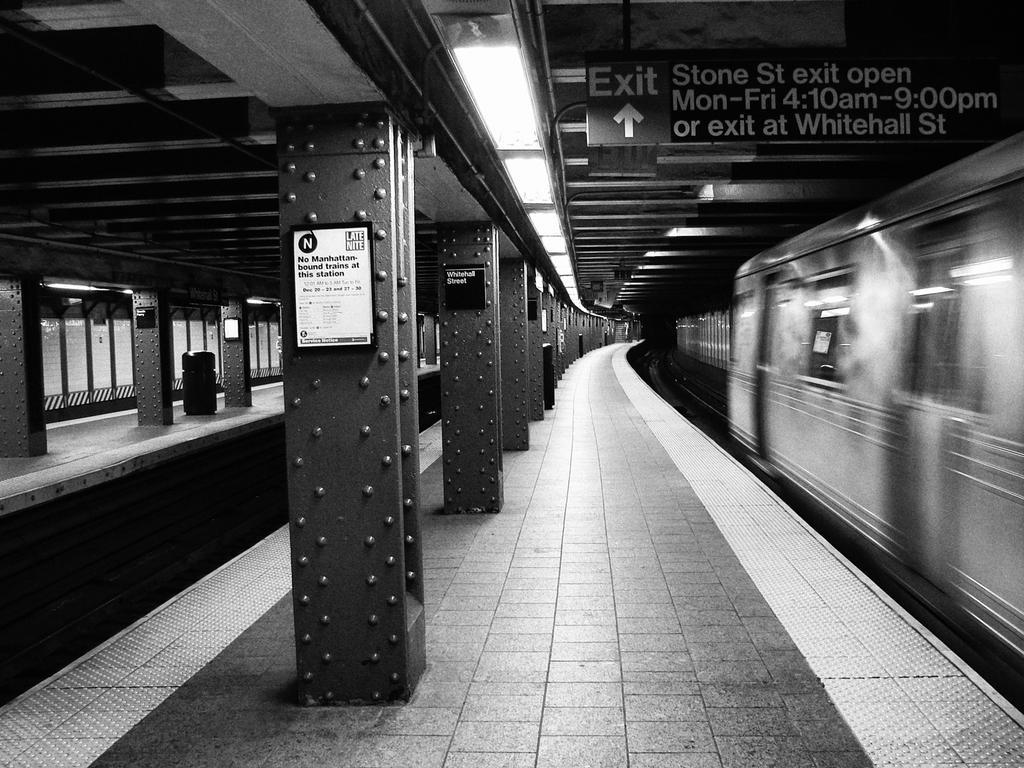How would you summarize this image in a sentence or two? In this black and white image, we can see pillars on platforms. There is a train on the right side of the image. There is a board in the top right of the image. There are some lights at the top of the image. 